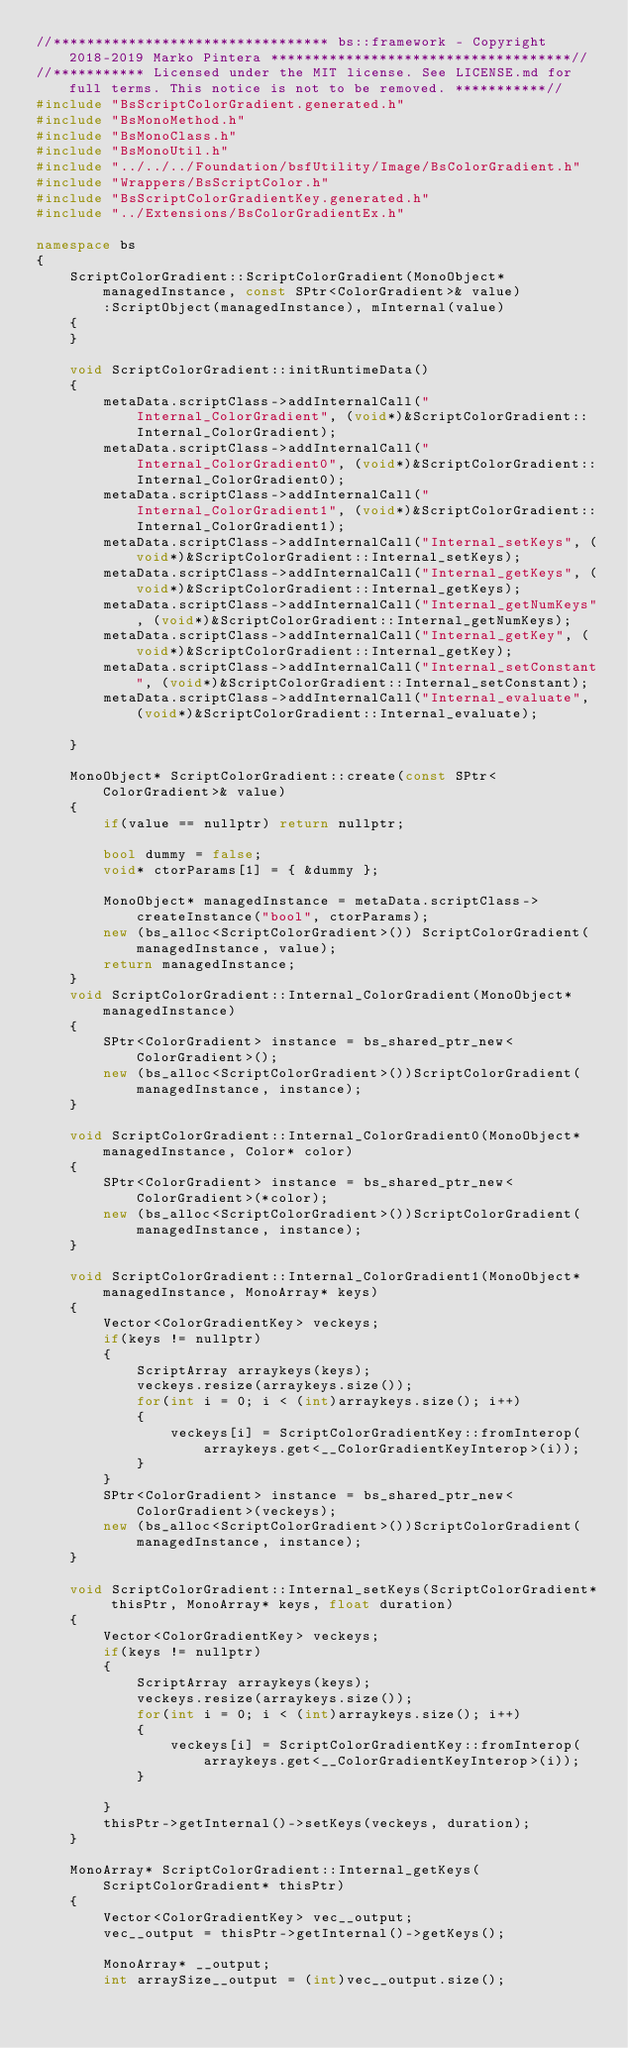<code> <loc_0><loc_0><loc_500><loc_500><_C++_>//********************************* bs::framework - Copyright 2018-2019 Marko Pintera ************************************//
//*********** Licensed under the MIT license. See LICENSE.md for full terms. This notice is not to be removed. ***********//
#include "BsScriptColorGradient.generated.h"
#include "BsMonoMethod.h"
#include "BsMonoClass.h"
#include "BsMonoUtil.h"
#include "../../../Foundation/bsfUtility/Image/BsColorGradient.h"
#include "Wrappers/BsScriptColor.h"
#include "BsScriptColorGradientKey.generated.h"
#include "../Extensions/BsColorGradientEx.h"

namespace bs
{
	ScriptColorGradient::ScriptColorGradient(MonoObject* managedInstance, const SPtr<ColorGradient>& value)
		:ScriptObject(managedInstance), mInternal(value)
	{
	}

	void ScriptColorGradient::initRuntimeData()
	{
		metaData.scriptClass->addInternalCall("Internal_ColorGradient", (void*)&ScriptColorGradient::Internal_ColorGradient);
		metaData.scriptClass->addInternalCall("Internal_ColorGradient0", (void*)&ScriptColorGradient::Internal_ColorGradient0);
		metaData.scriptClass->addInternalCall("Internal_ColorGradient1", (void*)&ScriptColorGradient::Internal_ColorGradient1);
		metaData.scriptClass->addInternalCall("Internal_setKeys", (void*)&ScriptColorGradient::Internal_setKeys);
		metaData.scriptClass->addInternalCall("Internal_getKeys", (void*)&ScriptColorGradient::Internal_getKeys);
		metaData.scriptClass->addInternalCall("Internal_getNumKeys", (void*)&ScriptColorGradient::Internal_getNumKeys);
		metaData.scriptClass->addInternalCall("Internal_getKey", (void*)&ScriptColorGradient::Internal_getKey);
		metaData.scriptClass->addInternalCall("Internal_setConstant", (void*)&ScriptColorGradient::Internal_setConstant);
		metaData.scriptClass->addInternalCall("Internal_evaluate", (void*)&ScriptColorGradient::Internal_evaluate);

	}

	MonoObject* ScriptColorGradient::create(const SPtr<ColorGradient>& value)
	{
		if(value == nullptr) return nullptr; 

		bool dummy = false;
		void* ctorParams[1] = { &dummy };

		MonoObject* managedInstance = metaData.scriptClass->createInstance("bool", ctorParams);
		new (bs_alloc<ScriptColorGradient>()) ScriptColorGradient(managedInstance, value);
		return managedInstance;
	}
	void ScriptColorGradient::Internal_ColorGradient(MonoObject* managedInstance)
	{
		SPtr<ColorGradient> instance = bs_shared_ptr_new<ColorGradient>();
		new (bs_alloc<ScriptColorGradient>())ScriptColorGradient(managedInstance, instance);
	}

	void ScriptColorGradient::Internal_ColorGradient0(MonoObject* managedInstance, Color* color)
	{
		SPtr<ColorGradient> instance = bs_shared_ptr_new<ColorGradient>(*color);
		new (bs_alloc<ScriptColorGradient>())ScriptColorGradient(managedInstance, instance);
	}

	void ScriptColorGradient::Internal_ColorGradient1(MonoObject* managedInstance, MonoArray* keys)
	{
		Vector<ColorGradientKey> veckeys;
		if(keys != nullptr)
		{
			ScriptArray arraykeys(keys);
			veckeys.resize(arraykeys.size());
			for(int i = 0; i < (int)arraykeys.size(); i++)
			{
				veckeys[i] = ScriptColorGradientKey::fromInterop(arraykeys.get<__ColorGradientKeyInterop>(i));
			}
		}
		SPtr<ColorGradient> instance = bs_shared_ptr_new<ColorGradient>(veckeys);
		new (bs_alloc<ScriptColorGradient>())ScriptColorGradient(managedInstance, instance);
	}

	void ScriptColorGradient::Internal_setKeys(ScriptColorGradient* thisPtr, MonoArray* keys, float duration)
	{
		Vector<ColorGradientKey> veckeys;
		if(keys != nullptr)
		{
			ScriptArray arraykeys(keys);
			veckeys.resize(arraykeys.size());
			for(int i = 0; i < (int)arraykeys.size(); i++)
			{
				veckeys[i] = ScriptColorGradientKey::fromInterop(arraykeys.get<__ColorGradientKeyInterop>(i));
			}

		}
		thisPtr->getInternal()->setKeys(veckeys, duration);
	}

	MonoArray* ScriptColorGradient::Internal_getKeys(ScriptColorGradient* thisPtr)
	{
		Vector<ColorGradientKey> vec__output;
		vec__output = thisPtr->getInternal()->getKeys();

		MonoArray* __output;
		int arraySize__output = (int)vec__output.size();</code> 